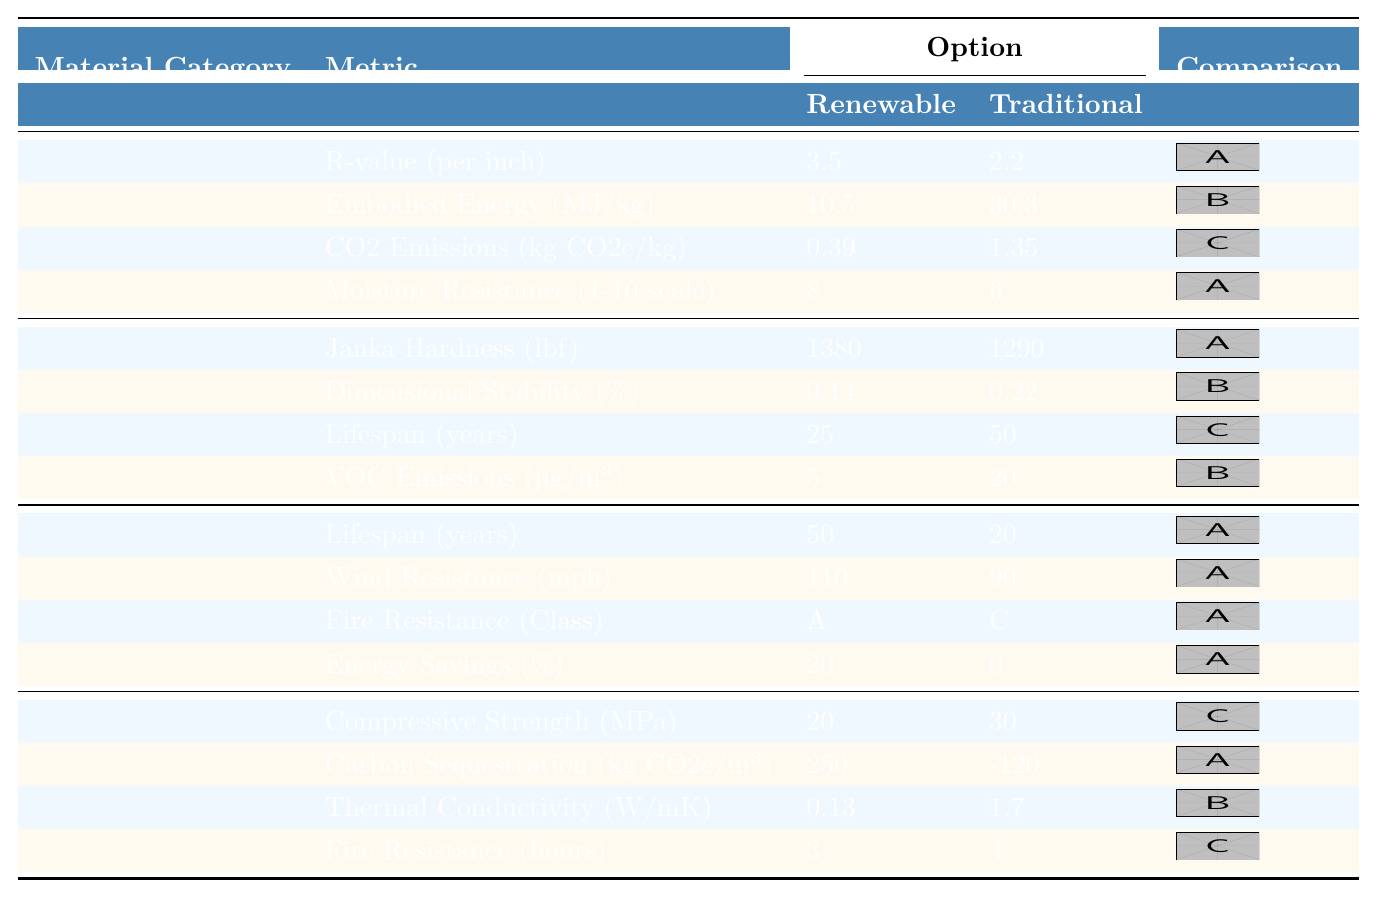What is the R-value per inch of Hemp Insulation? The table shows that the R-value per inch for Hemp Insulation is listed under the insulation category as 3.5.
Answer: 3.5 Which material option has lower embodied energy, Renewable or Traditional? The table indicates that the embodied energy for Hemp Insulation (renewable) is 10.5 MJ/kg while for Fiberglass Insulation (traditional) it is 30.3 MJ/kg. Clearly, the renewable option has lower embodied energy.
Answer: Renewable What is the difference in CO2 emissions between Hemp Insulation and Fiberglass Insulation? The CO2 emissions for Hemp Insulation is 0.39 kg CO2e/kg and for Fiberglass Insulation is 1.35 kg CO2e/kg. The difference is calculated as 1.35 - 0.39 = 0.96.
Answer: 0.96 kg CO2e/kg How much longer does Bamboo last compared to Hardwood? The lifespan of Bamboo is 25 years and for Hardwood it is 50 years. The difference in lifespan is 50 - 25 = 25 years, indicating Bamboo lasts 25 years shorter.
Answer: 25 years shorter Is the Janka hardness of Bamboo greater than that of Hardwood? The table shows that Bamboo has a Janka Hardness of 1380 lbf, while Hardwood has a hardness of 1290 lbf, confirming that Bamboo is indeed harder.
Answer: Yes What is the overall trend in lifespan for Roofing materials? Comparing Renewables and Traditionals, Renewable options (Recycled Rubber Shingles) have a lifespan of 50 years while Traditional options (Asphalt Shingles) last only 20 years. This shows a significant improvement in lifespan for the renewable roofing material.
Answer: Renewable lasts longer What is the average wind resistance of the two roofing materials? Wind Resistance for Recycled Rubber Shingles is 110 mph and for Asphalt Shingles is 90 mph. The average is calculated as (110 + 90) / 2 = 100 mph.
Answer: 100 mph What advantages does Cross-Laminated Timber offer over Reinforced Concrete in terms of carbon sequestration? The table shows that Cross-Laminated Timber sequesters 250 kg CO2e/m³ whereas Reinforced Concrete has a negative sequestration of -120 kg CO2e/m³. This means Cross-Laminated Timber is advantageous as it stores carbon while Reinforced Concrete contributes to emissions.
Answer: Yes, it is advantageous If we consider fire resistance, which structural material is better? Cross-Laminated Timber has a fire resistance rating of 3 hours while Reinforced Concrete has 4 hours. Despite being higher, it’s important to recognize that the choice may depend on other factors; however, strictly on fire resistance, Reinforced Concrete performs better here.
Answer: Reinforced Concrete Which material has the lowest VOC emissions and what is the value? The table shows that the Renewable option for flooring (Bamboo) has VOC emissions of 5 µg/m³, while the Traditional option (Hardwood) has 20 µg/m³, making Bamboo the lower-emission choice.
Answer: 5 µg/m³ 